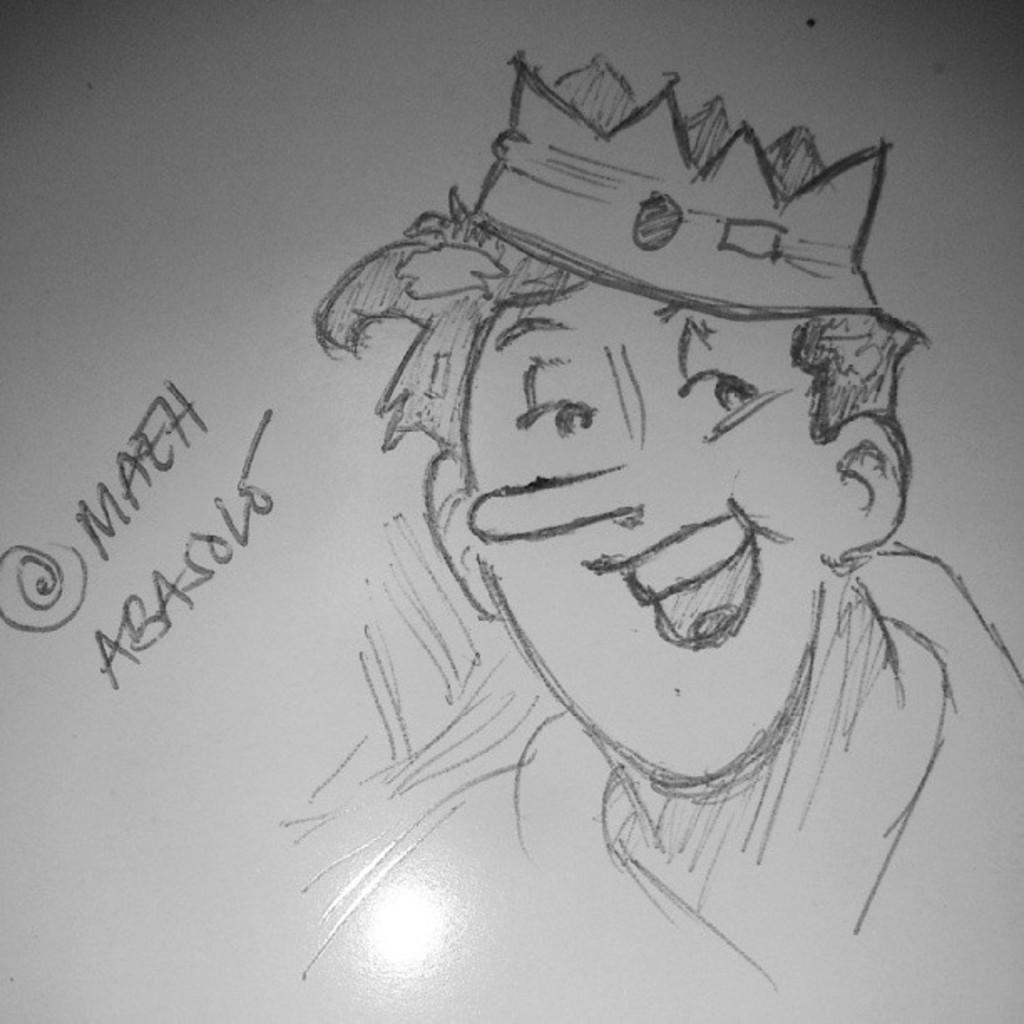Describe this image in one or two sentences. In this image we can see a sketch of a person, beside the person there is some text. 